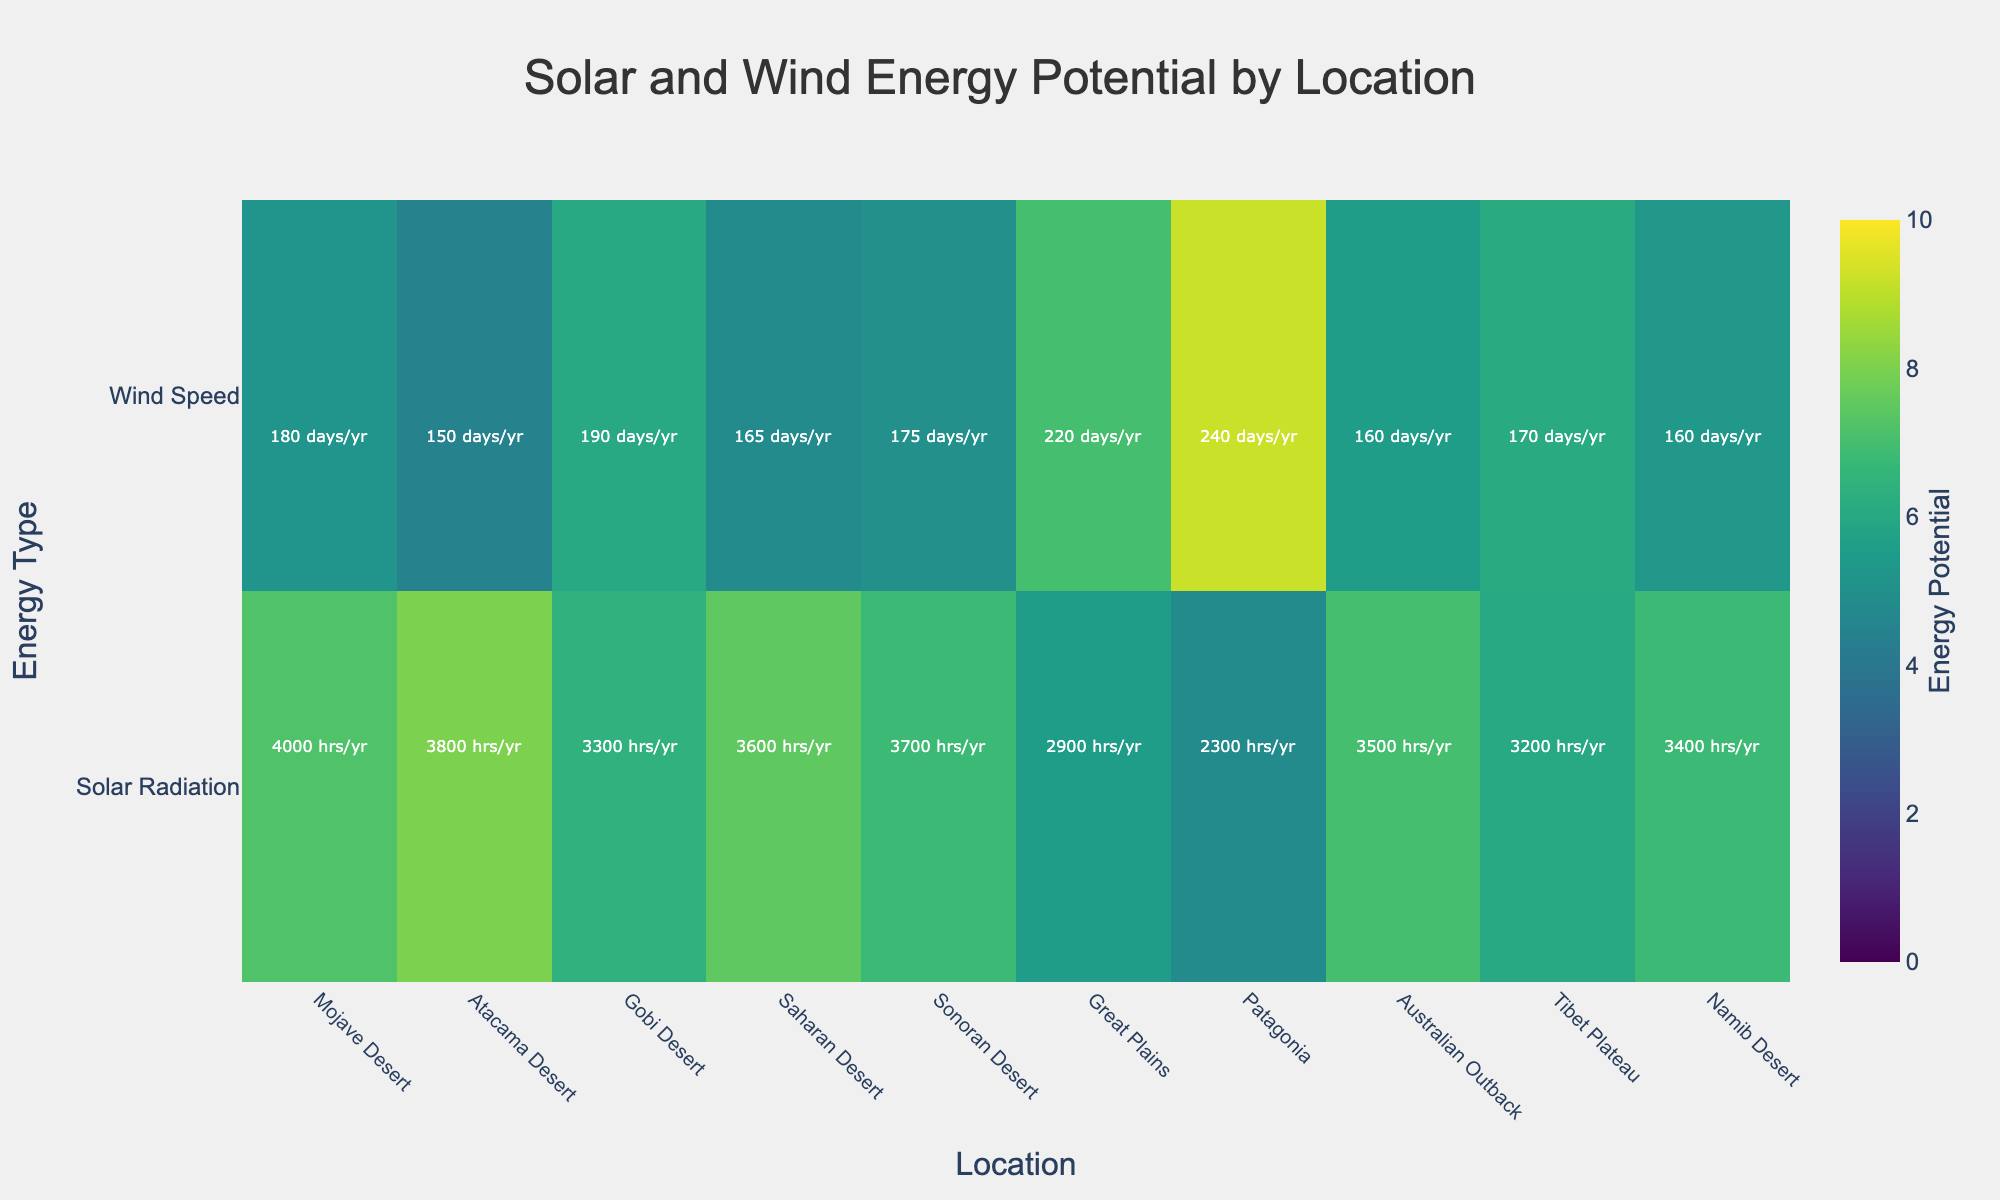What is the location with the highest average solar radiation? By looking at the heatmap and focusing on the "Solar Radiation" row, you can see which bar has the highest color intensity. The Atacama Desert stands out with the highest value for solar radiation.
Answer: Atacama Desert Which location has the highest average wind speed? By examining the "Wind Speed" row, you can identify the bar with the highest intensity. Patagonia shows the highest average wind speed as indicated by the most intense coloration in its column.
Answer: Patagonia How many locations have average solar radiation above 7.0 kWh/m2/day? To find this, refer to the "Solar Radiation" row and count the columns where the intensity indicates a value above 7.0 kWh/m2/day. There are five locations: Mojave Desert, Atacama Desert, Saharan Desert, Australian Outback, and Namib Desert.
Answer: 5 Compare the historical sunshine hours per year in the Mojave Desert and the Tibet Plateau. By looking at the annotations in the "Solar Radiation" row for both locations: Mojave Desert shows 4000 hrs/yr and Tibet Plateau shows 3200 hrs/yr. Therefore, Mojave Desert has more sunshine hours.
Answer: Mojave Desert What is the smallest average wind speed among all locations? By looking at the "Wind Speed" row and identifying the lowest intensity column, Atacama Desert has the smallest average wind speed of 4.5 m/s.
Answer: Atacama Desert Which location has the highest potential for wind energy based on both average wind speed and historical wind days per year? By examining the heatmap for the highest intensity in "Wind Speed" and cross-referencing with annotations for historical wind days, Patagonia stands out with the highest wind speed and 240 wind days per year.
Answer: Patagonia What is the average historical sunshine hours per year for locations with average solar radiation above 7.0 kWh/m2/day? The locations are Mojave Desert (4000 hrs), Atacama Desert (3800 hrs), Saharan Desert (3600 hrs), Australian Outback (3500 hrs), and Namib Desert (3400 hrs). The average is calculated as (4000 + 3800 + 3600 + 3500 + 3400)/5 = 3660 hrs/yr.
Answer: 3660 hrs/yr Which location has the closest values of average solar radiation and average wind speed? By observing the heatmap, the location where the color intensities in both "Solar Radiation" and "Wind Speed" rows are closest to each other would be the Sonoran Desert, with 6.8 kWh/m2/day for solar radiation and 5.0 m/s for wind speed.
Answer: Sonoran Desert 